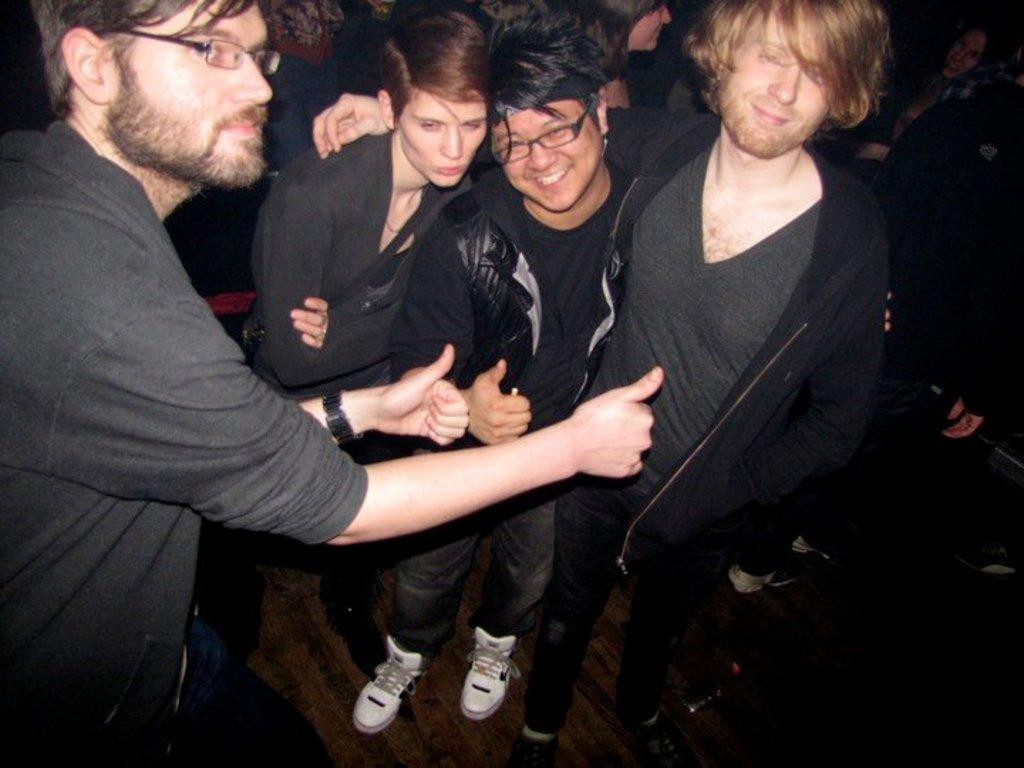What is the main subject of the image? The main subject of the image is a group of people. What color are the dresses worn by the people in the image? The people in the image are wearing black color dresses. How many people with specs can be seen in the image? There are two people with specs visible in the image. Can you describe the people in the background of the image? There are more people visible in the background of the image. What type of powder can be seen falling from the sky in the image? There is no powder falling from the sky in the image. Is there a quilt visible in the image? There is no quilt present in the image. 